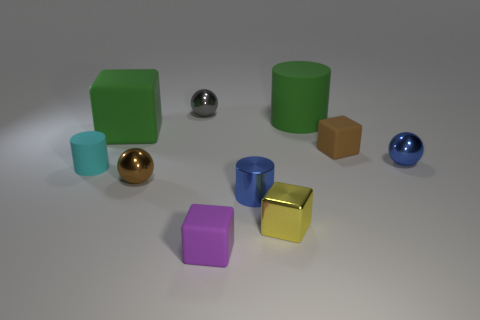What shape is the tiny blue object to the left of the tiny blue metal thing behind the tiny blue metal cylinder that is in front of the big matte cylinder?
Provide a short and direct response. Cylinder. How big is the yellow thing?
Your answer should be compact. Small. There is a tiny brown thing that is made of the same material as the gray ball; what shape is it?
Your answer should be very brief. Sphere. Are there fewer tiny brown rubber cubes that are in front of the tiny cyan object than small purple objects?
Make the answer very short. Yes. What color is the big rubber cylinder right of the tiny brown ball?
Offer a terse response. Green. There is a thing that is the same color as the big rubber cube; what is it made of?
Keep it short and to the point. Rubber. Are there any other tiny objects of the same shape as the small brown rubber thing?
Make the answer very short. Yes. What number of green rubber objects are the same shape as the brown matte thing?
Make the answer very short. 1. Is the big cube the same color as the big cylinder?
Offer a terse response. Yes. Is the number of purple rubber blocks less than the number of tiny shiny balls?
Provide a succinct answer. Yes. 